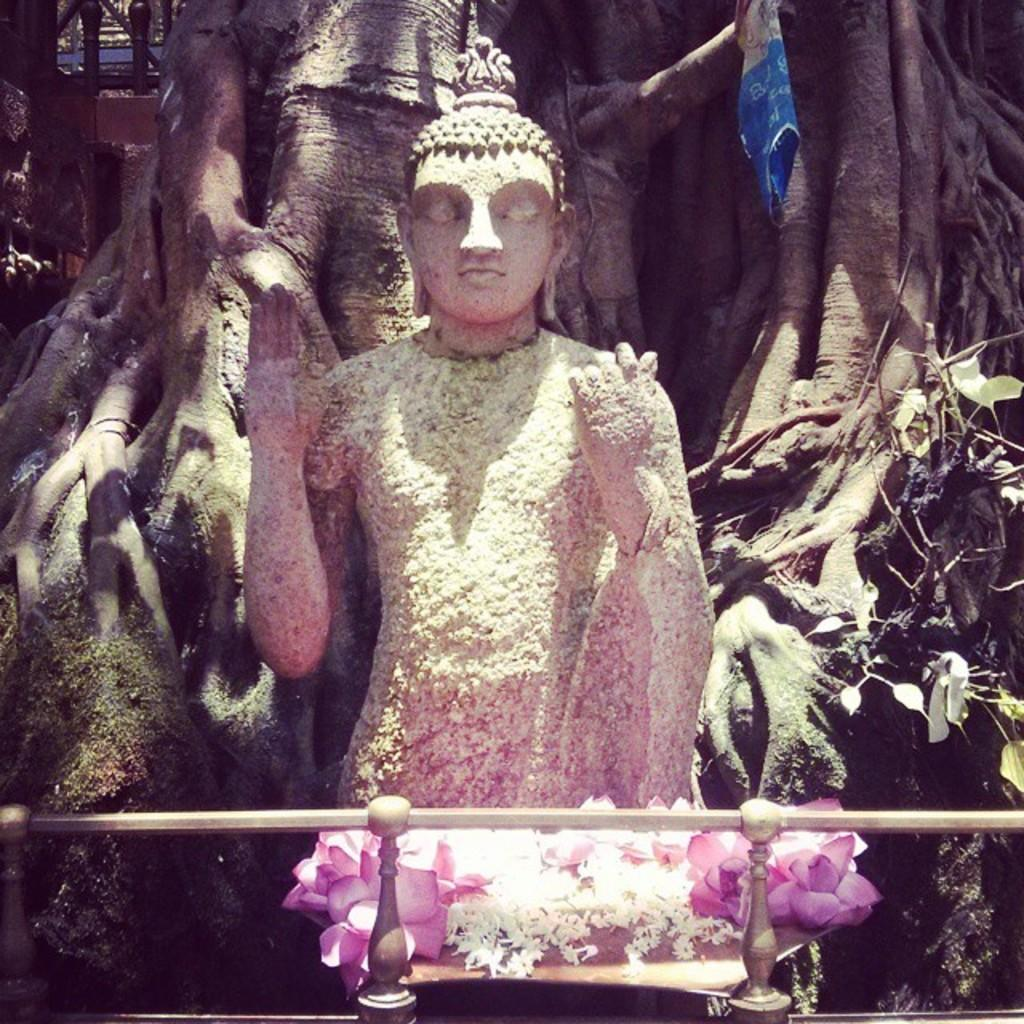What is the main subject of the image? There is a Buddha statue in the image. What can be seen around the Buddha statue? There are flowers in the image, with colors pink and white. What is visible in the background of the image? There is a tree with visible roots in the background of the image. How does the spoon affect the friction between the Buddha statue and the flowers in the image? There is no spoon present in the image, so it cannot affect the friction between the Buddha statue and the flowers. 